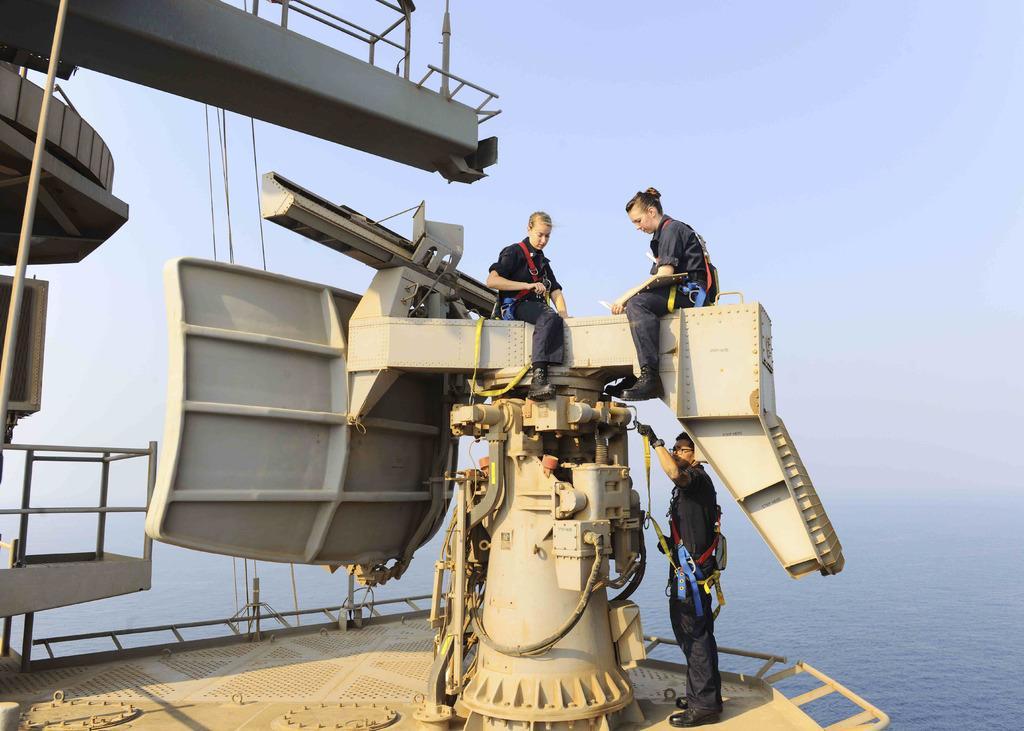How would you summarize this image in a sentence or two? Here we can see two women sitting on a metal object and a man is standing on a platform. On the left we can see a metal object. In the background we can see water and sky. 